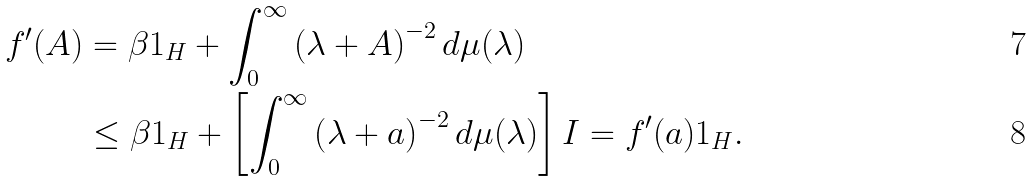<formula> <loc_0><loc_0><loc_500><loc_500>f ^ { \prime } ( A ) & = \beta 1 _ { H } + \int _ { 0 } ^ { \infty } \left ( \lambda + A \right ) ^ { - 2 } d \mu ( \lambda ) \\ & \leq \beta 1 _ { H } + \left [ \int _ { 0 } ^ { \infty } \left ( \lambda + a \right ) ^ { - 2 } d \mu ( \lambda ) \right ] I = f ^ { \prime } ( a ) 1 _ { H } .</formula> 